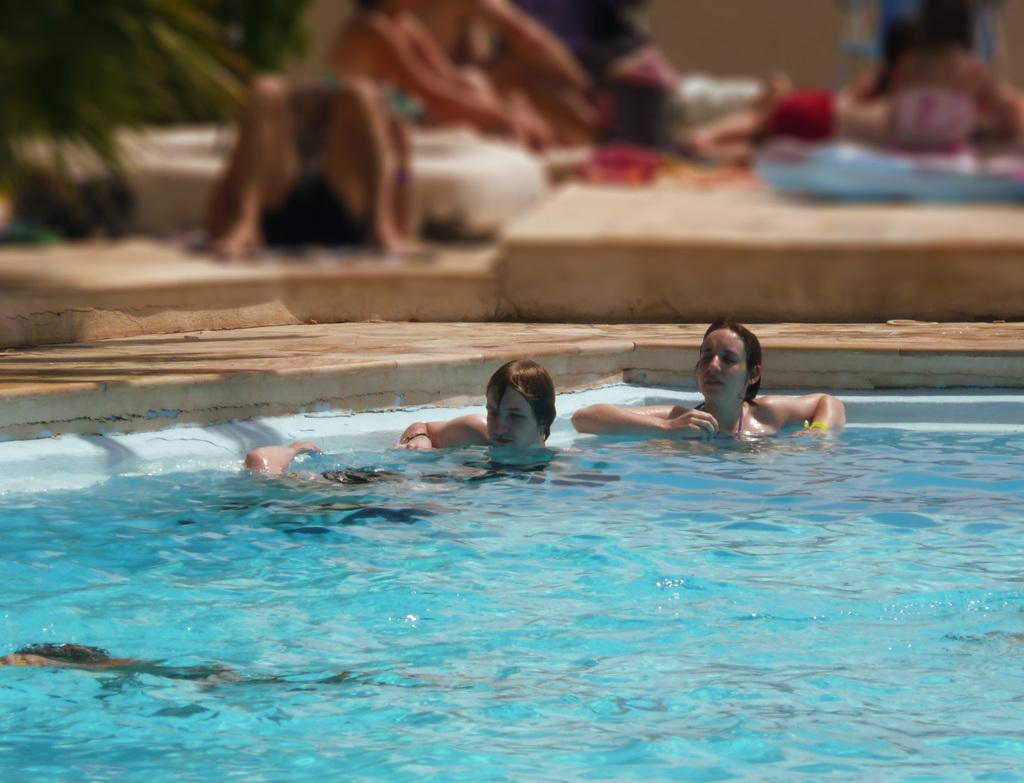What activity are the people in the image engaged in? The people in the image are in a swimming pool. Are there any people not in the pool in the image? Yes, there are people resting on the floor in the image. What can be seen on the left side of the image? There are plants on the left side of the image. What type of destruction can be seen in the image? There is no destruction present in the image; it features people swimming and resting, as well as plants. Can you tell me how many secretaries are in the image? There are no secretaries present in the image. 